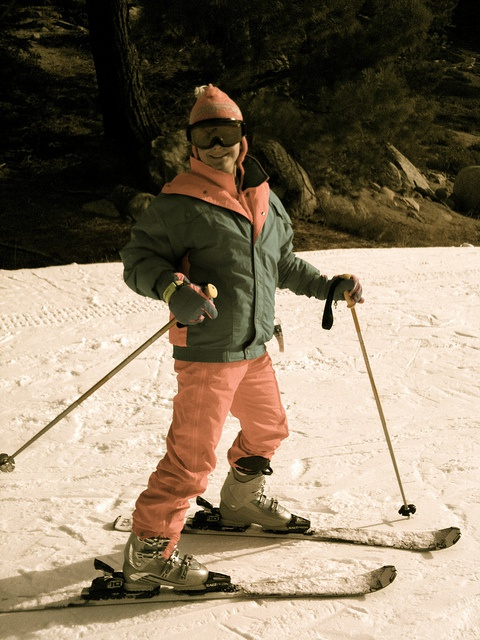Describe the objects in this image and their specific colors. I can see people in black, olive, brown, and red tones, skis in black, olive, beige, and tan tones, and skis in black, olive, and tan tones in this image. 